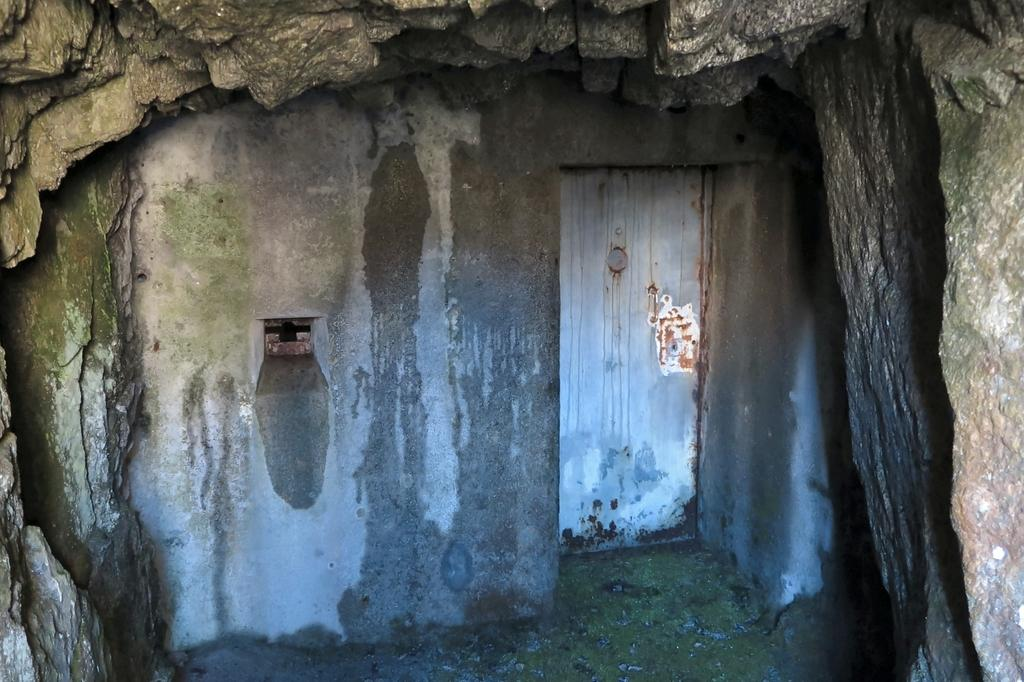What type of structure is depicted in the image? The image appears to depict a cave. What are the main features of the cave? There is a wall and a door visible in the image. How would you describe the appearance of the cave's top? The cave has a rocky appearance at the top. What type of chair can be seen inside the cave in the image? There is no chair present in the image; it depicts a cave with a wall, door, and rocky appearance at the top. 